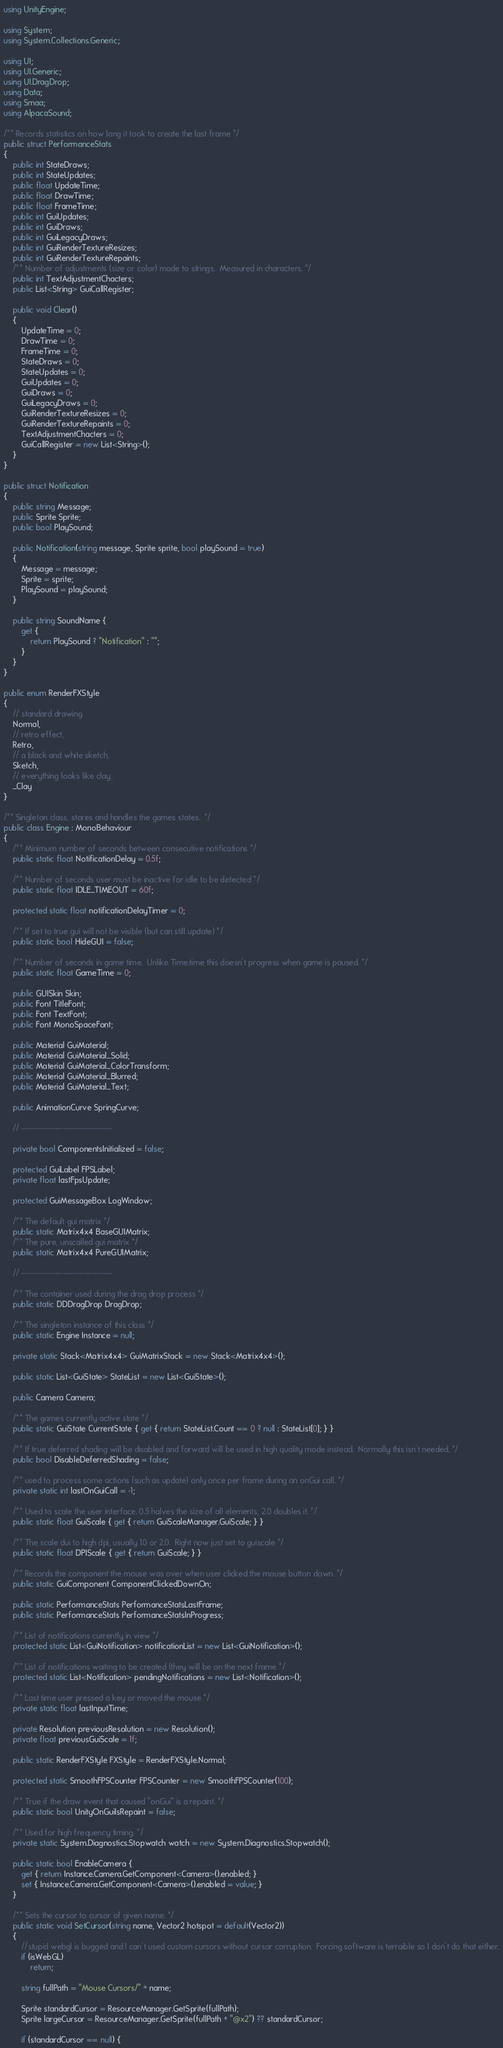<code> <loc_0><loc_0><loc_500><loc_500><_C#_>using UnityEngine;

using System;
using System.Collections.Generic;

using UI;
using UI.Generic;
using UI.DragDrop;
using Data;
using Smaa;
using AlpacaSound;

/** Records statistics on how long it took to create the last frame */
public struct PerformanceStats
{
	public int StateDraws;
	public int StateUpdates;
	public float UpdateTime;
	public float DrawTime;
	public float FrameTime;
	public int GuiUpdates;
	public int GuiDraws;
	public int GuiLegacyDraws;
	public int GuiRenderTextureResizes;
	public int GuiRenderTextureRepaints;
	/** Number of adjustments (size or color) made to strings.  Measured in characters. */
	public int TextAdjustmentChacters;
	public List<String> GuiCallRegister;

	public void Clear()
	{
		UpdateTime = 0;
		DrawTime = 0;
		FrameTime = 0;
		StateDraws = 0;
		StateUpdates = 0;
		GuiUpdates = 0;
		GuiDraws = 0;
		GuiLegacyDraws = 0;
		GuiRenderTextureResizes = 0;
		GuiRenderTextureRepaints = 0;
		TextAdjustmentChacters = 0;
		GuiCallRegister = new List<String>();
	}
}

public struct Notification
{
	public string Message;
	public Sprite Sprite;
	public bool PlaySound;

	public Notification(string message, Sprite sprite, bool playSound = true)
	{
		Message = message;
		Sprite = sprite;
		PlaySound = playSound;
	}

	public string SoundName {
		get { 
			return PlaySound ? "Notification" : "";
		}
	}
}

public enum RenderFXStyle
{
	// standard drawing
	Normal,
	// retro effect,
	Retro,
	// a black and white sketch,
	Sketch,
	// everything looks like clay,
	_Clay
}

/** Singleton class, stores and handles the games states.  */
public class Engine : MonoBehaviour
{
	/** Minimum number of seconds between consecutive notifications */ 
	public static float NotificationDelay = 0.5f;

	/** Number of seconds user must be inactive for idle to be detected */
	public static float IDLE_TIMEOUT = 60f;

	protected static float notificationDelayTimer = 0;

	/** If set to true gui will not be visible (but can still update) */
	public static bool HideGUI = false;

	/** Number of seconds in game time.  Unlike Time.time this doesn't progress when game is paused. */
	public static float GameTime = 0;

	public GUISkin Skin;
	public Font TitleFont;
	public Font TextFont;
	public Font MonoSpaceFont;

	public Material GuiMaterial;
	public Material GuiMaterial_Solid;
	public Material GuiMaterial_ColorTransform;
	public Material GuiMaterial_Blurred;
	public Material GuiMaterial_Text;

	public AnimationCurve SpringCurve;

	// -----------------------------------

	private bool ComponentsInitialized = false;

	protected GuiLabel FPSLabel;
	private float lastFpsUpdate;

	protected GuiMessageBox LogWindow;

	/** The default gui matrix */
	public static Matrix4x4 BaseGUIMatrix;
	/** The pure, unscalled gui matrix */
	public static Matrix4x4 PureGUIMatrix;

	// -----------------------------------

	/** The container used during the drag drop process */
	public static DDDragDrop DragDrop;
	
	/** The singleton instance of this class */
	public static Engine Instance = null;

	private static Stack<Matrix4x4> GuiMatrixStack = new Stack<Matrix4x4>();

	public static List<GuiState> StateList = new List<GuiState>();

	public Camera Camera;

	/** The games currently active state */
	public static GuiState CurrentState { get { return StateList.Count == 0 ? null : StateList[0]; } }

	/** If true deferred shading will be disabled and forward will be used in high quality mode instead.  Normally this isn't needed. */
	public bool DisableDeferredShading = false;

	/** used to process some actions (such as update) only once per frame during an onGui call. */
	private static int lastOnGuiCall = -1;

	/** Used to scale the user interface. 0.5 halves the size of all elements, 2.0 doubles it. */
	public static float GuiScale { get { return GuiScaleManager.GuiScale; } }

	/** The scale dui to high dpi, usually 1.0 or 2.0.  Right now just set to guiscale */
	public static float DPIScale { get { return GuiScale; } }

	/** Records the component the mouse was over when user clicked the mouse button down. */
	public static GuiComponent ComponentClickedDownOn;

	public static PerformanceStats PerformanceStatsLastFrame;
	public static PerformanceStats PerformanceStatsInProgress;

	/** List of notifications currently in view */
	protected static List<GuiNotification> notificationList = new List<GuiNotification>();

	/** List of notifications waiting to be created (they will be on the next frame */
	protected static List<Notification> pendingNotifications = new List<Notification>();

	/** Last time user pressed a key or moved the mouse */
	private static float lastInputTime;

	private Resolution previousResolution = new Resolution();
	private float previousGuiScale = 1f;

	public static RenderFXStyle FXStyle = RenderFXStyle.Normal;

	protected static SmoothFPSCounter FPSCounter = new SmoothFPSCounter(100);

	/** True if the draw event that caused "onGui" is a repaint. */
	public static bool UnityOnGuiIsRepaint = false;

	/** Used for high frequency timing. */
	private static System.Diagnostics.Stopwatch watch = new System.Diagnostics.Stopwatch();

	public static bool EnableCamera {
		get { return Instance.Camera.GetComponent<Camera>().enabled; }
		set { Instance.Camera.GetComponent<Camera>().enabled = value; }
	}

	/** Sets the cursor to cursor of given name. */
	public static void SetCursor(string name, Vector2 hotspot = default(Vector2))
	{
		//stupid webgl is bugged and I can't used custom cursors without cursor corruption.  Forcing software is terraible so I don't do that either.
		if (isWebGL)
			return;

		string fullPath = "Mouse Cursors/" + name;

		Sprite standardCursor = ResourceManager.GetSprite(fullPath);
		Sprite largeCursor = ResourceManager.GetSprite(fullPath + "@x2") ?? standardCursor;

		if (standardCursor == null) {</code> 